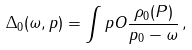Convert formula to latex. <formula><loc_0><loc_0><loc_500><loc_500>\Delta _ { 0 } ( \omega , p ) = \int p O \frac { \rho _ { 0 } ( P ) } { p _ { 0 } - \omega } \, ,</formula> 